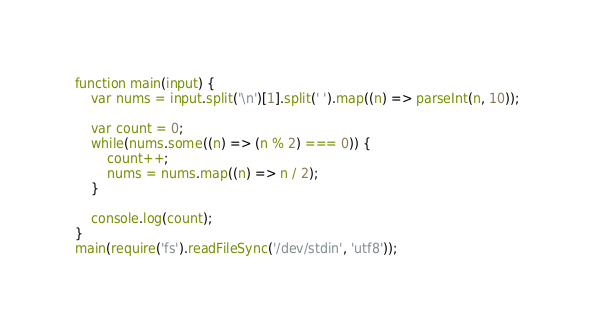Convert code to text. <code><loc_0><loc_0><loc_500><loc_500><_JavaScript_>function main(input) {
    var nums = input.split('\n')[1].split(' ').map((n) => parseInt(n, 10));
 
    var count = 0;
    while(nums.some((n) => (n % 2) === 0)) {
        count++;
        nums = nums.map((n) => n / 2);
    }
 
    console.log(count);
}
main(require('fs').readFileSync('/dev/stdin', 'utf8'));</code> 